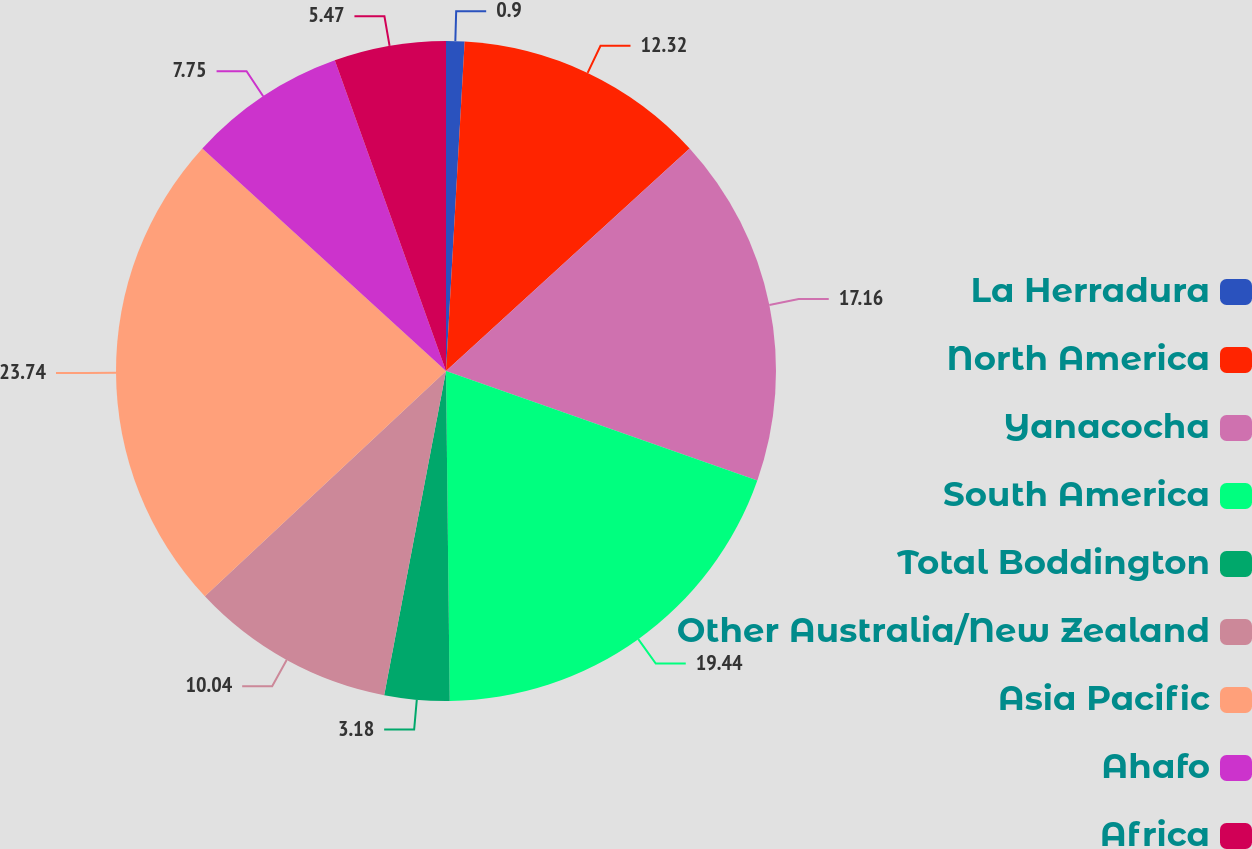Convert chart to OTSL. <chart><loc_0><loc_0><loc_500><loc_500><pie_chart><fcel>La Herradura<fcel>North America<fcel>Yanacocha<fcel>South America<fcel>Total Boddington<fcel>Other Australia/New Zealand<fcel>Asia Pacific<fcel>Ahafo<fcel>Africa<nl><fcel>0.9%<fcel>12.32%<fcel>17.16%<fcel>19.44%<fcel>3.18%<fcel>10.04%<fcel>23.74%<fcel>7.75%<fcel>5.47%<nl></chart> 